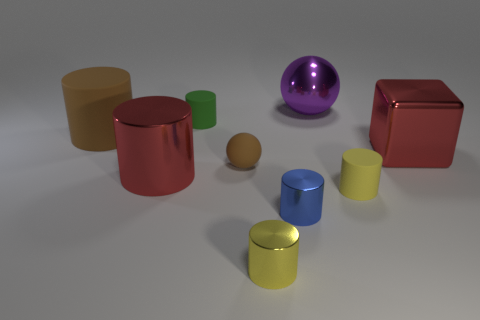Subtract all blue cylinders. How many cylinders are left? 5 Subtract 2 cylinders. How many cylinders are left? 4 Subtract all small green cylinders. How many cylinders are left? 5 Subtract all green cylinders. Subtract all red blocks. How many cylinders are left? 5 Add 1 tiny red rubber spheres. How many objects exist? 10 Subtract all cylinders. How many objects are left? 3 Add 7 large purple balls. How many large purple balls are left? 8 Add 1 large shiny things. How many large shiny things exist? 4 Subtract 0 purple cubes. How many objects are left? 9 Subtract all metal things. Subtract all rubber cylinders. How many objects are left? 1 